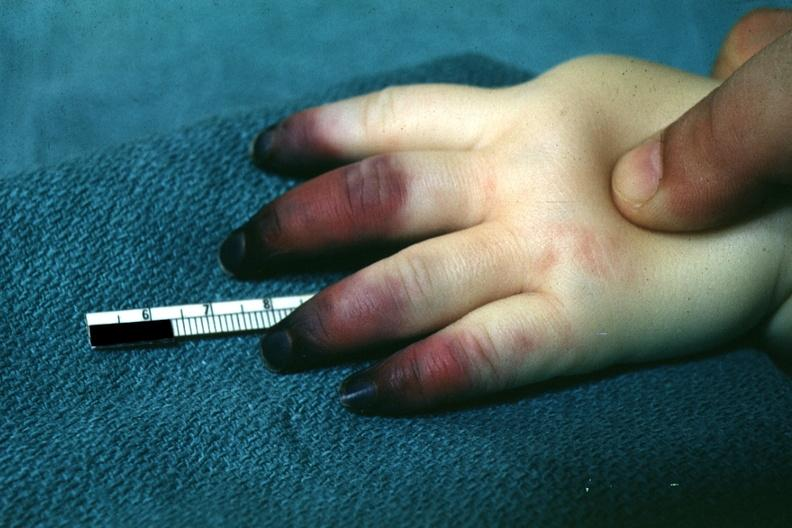what is present?
Answer the question using a single word or phrase. Hand 